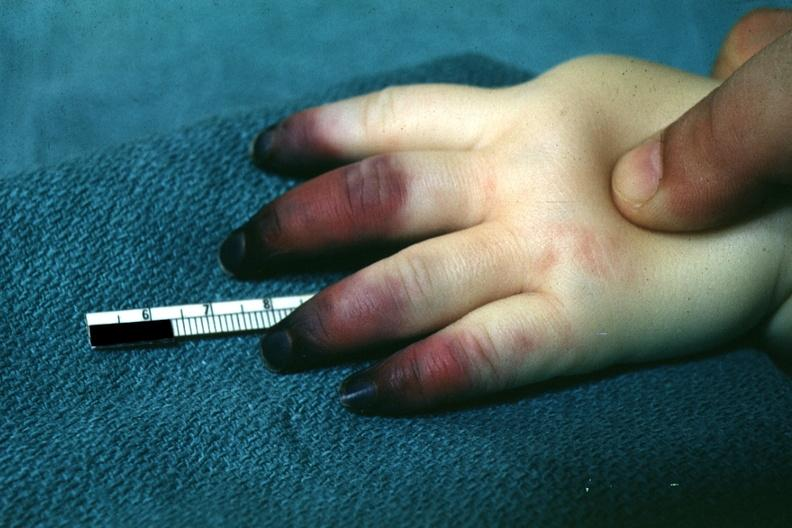what is present?
Answer the question using a single word or phrase. Hand 